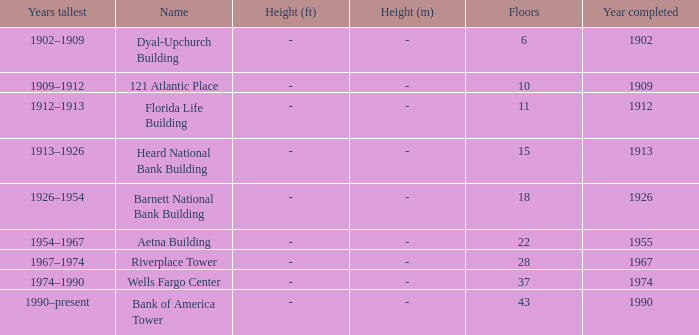What was the name of the building with 10 floors? 121 Atlantic Place. 